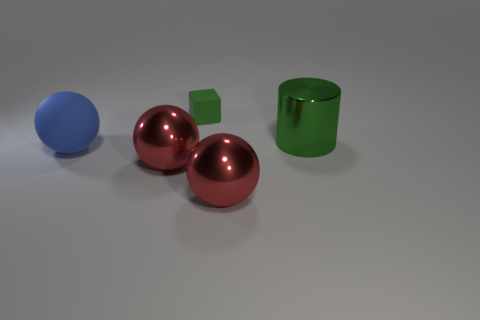Add 3 small gray things. How many objects exist? 8 Subtract all blocks. How many objects are left? 4 Add 2 large blue rubber objects. How many large blue rubber objects exist? 3 Subtract 0 gray cylinders. How many objects are left? 5 Subtract all green metal cylinders. Subtract all blocks. How many objects are left? 3 Add 5 big red objects. How many big red objects are left? 7 